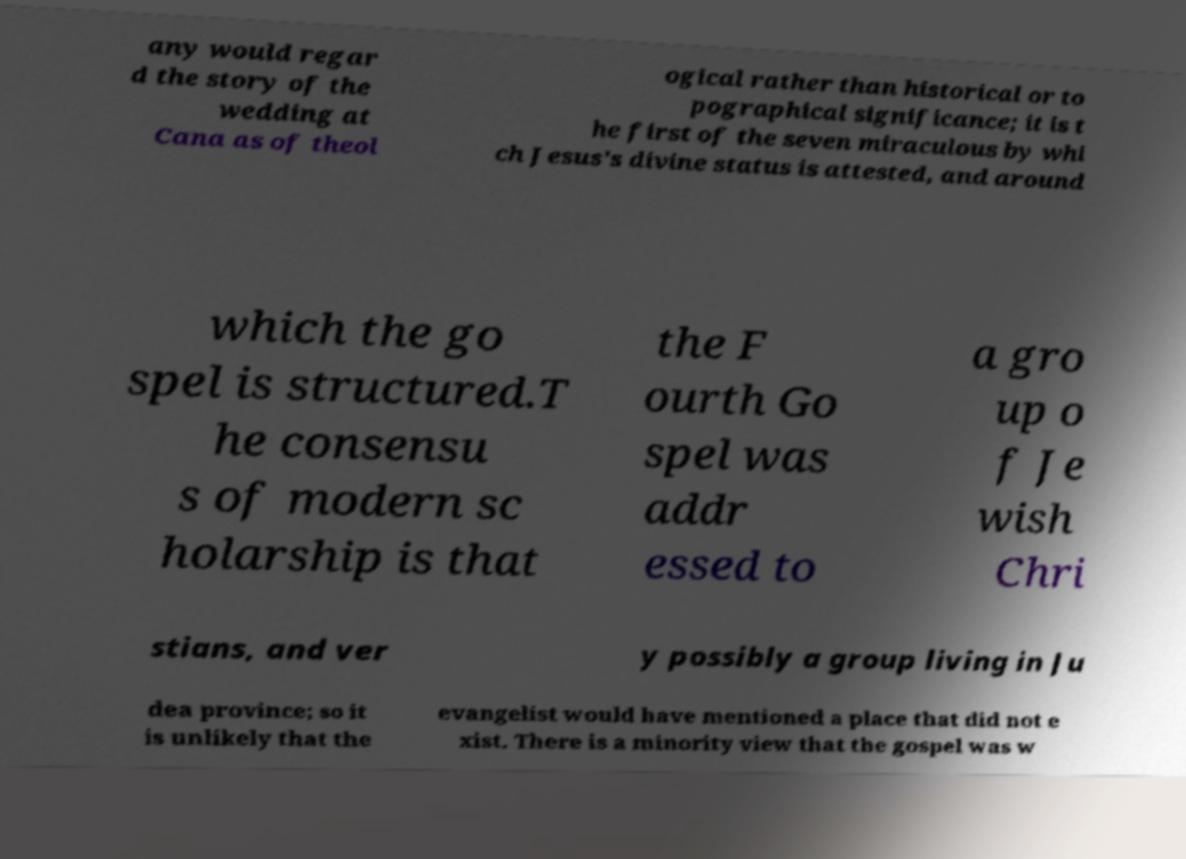Could you assist in decoding the text presented in this image and type it out clearly? any would regar d the story of the wedding at Cana as of theol ogical rather than historical or to pographical significance; it is t he first of the seven miraculous by whi ch Jesus's divine status is attested, and around which the go spel is structured.T he consensu s of modern sc holarship is that the F ourth Go spel was addr essed to a gro up o f Je wish Chri stians, and ver y possibly a group living in Ju dea province; so it is unlikely that the evangelist would have mentioned a place that did not e xist. There is a minority view that the gospel was w 